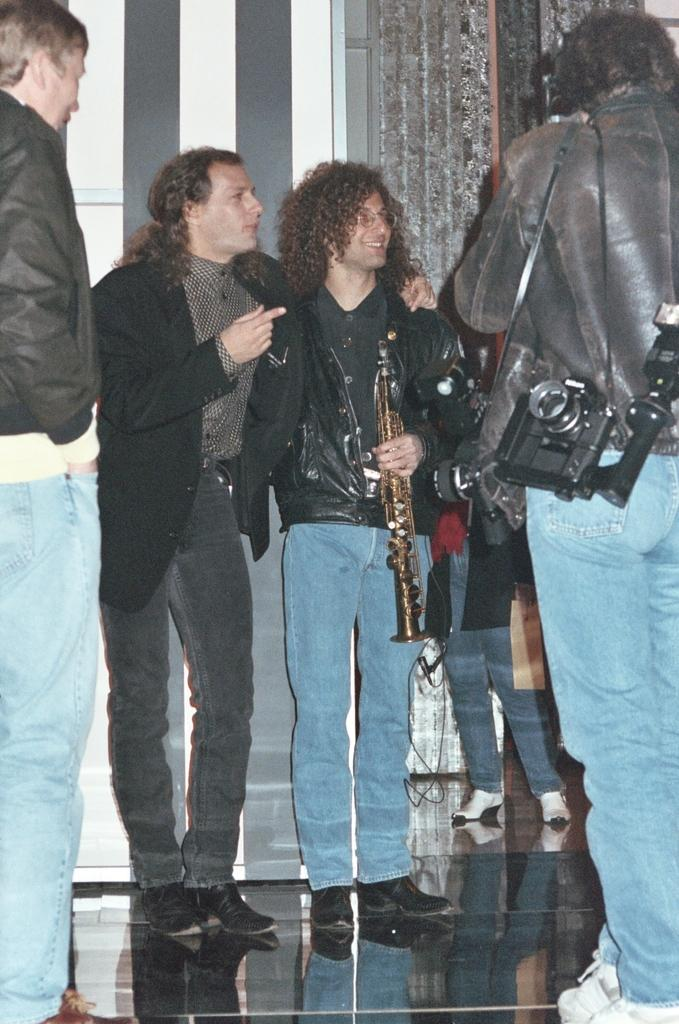What can be observed about the people in the image? There are people standing in the image, and they are wearing clothes and shoes. What are some of the people doing in the image? Some people are carrying objects, and there is a musical instrument in the image. What is the surface beneath the people in the image? There is a floor visible in the image. What type of sail can be seen on the boat in the image? There is no boat or sail present in the image; it features people standing and carrying objects. How does the hair of the people in the image look? The provided facts do not mention the hair of the people in the image, so we cannot determine its appearance. 